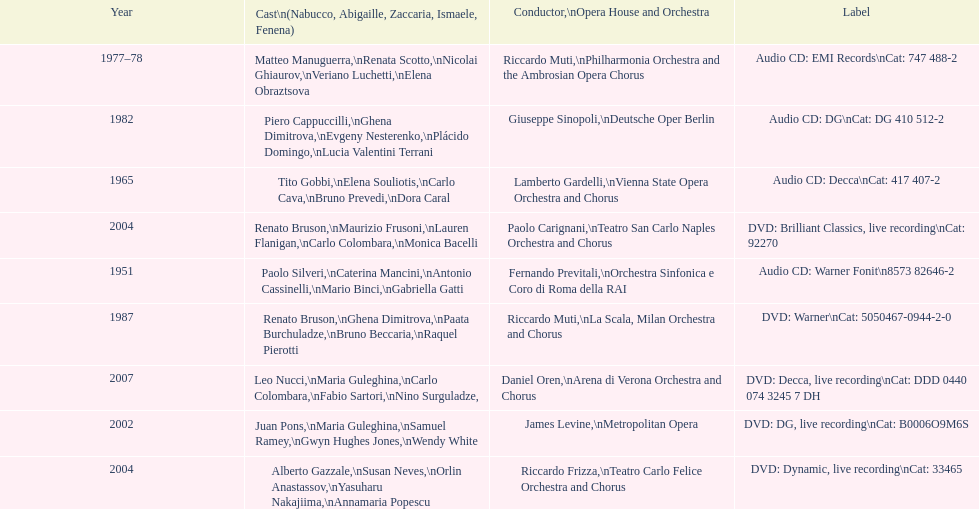When was the recording of nabucco made in the metropolitan opera? 2002. 